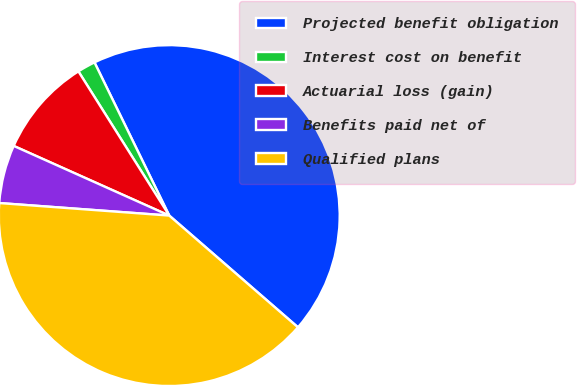Convert chart to OTSL. <chart><loc_0><loc_0><loc_500><loc_500><pie_chart><fcel>Projected benefit obligation<fcel>Interest cost on benefit<fcel>Actuarial loss (gain)<fcel>Benefits paid net of<fcel>Qualified plans<nl><fcel>43.6%<fcel>1.72%<fcel>9.35%<fcel>5.53%<fcel>39.79%<nl></chart> 